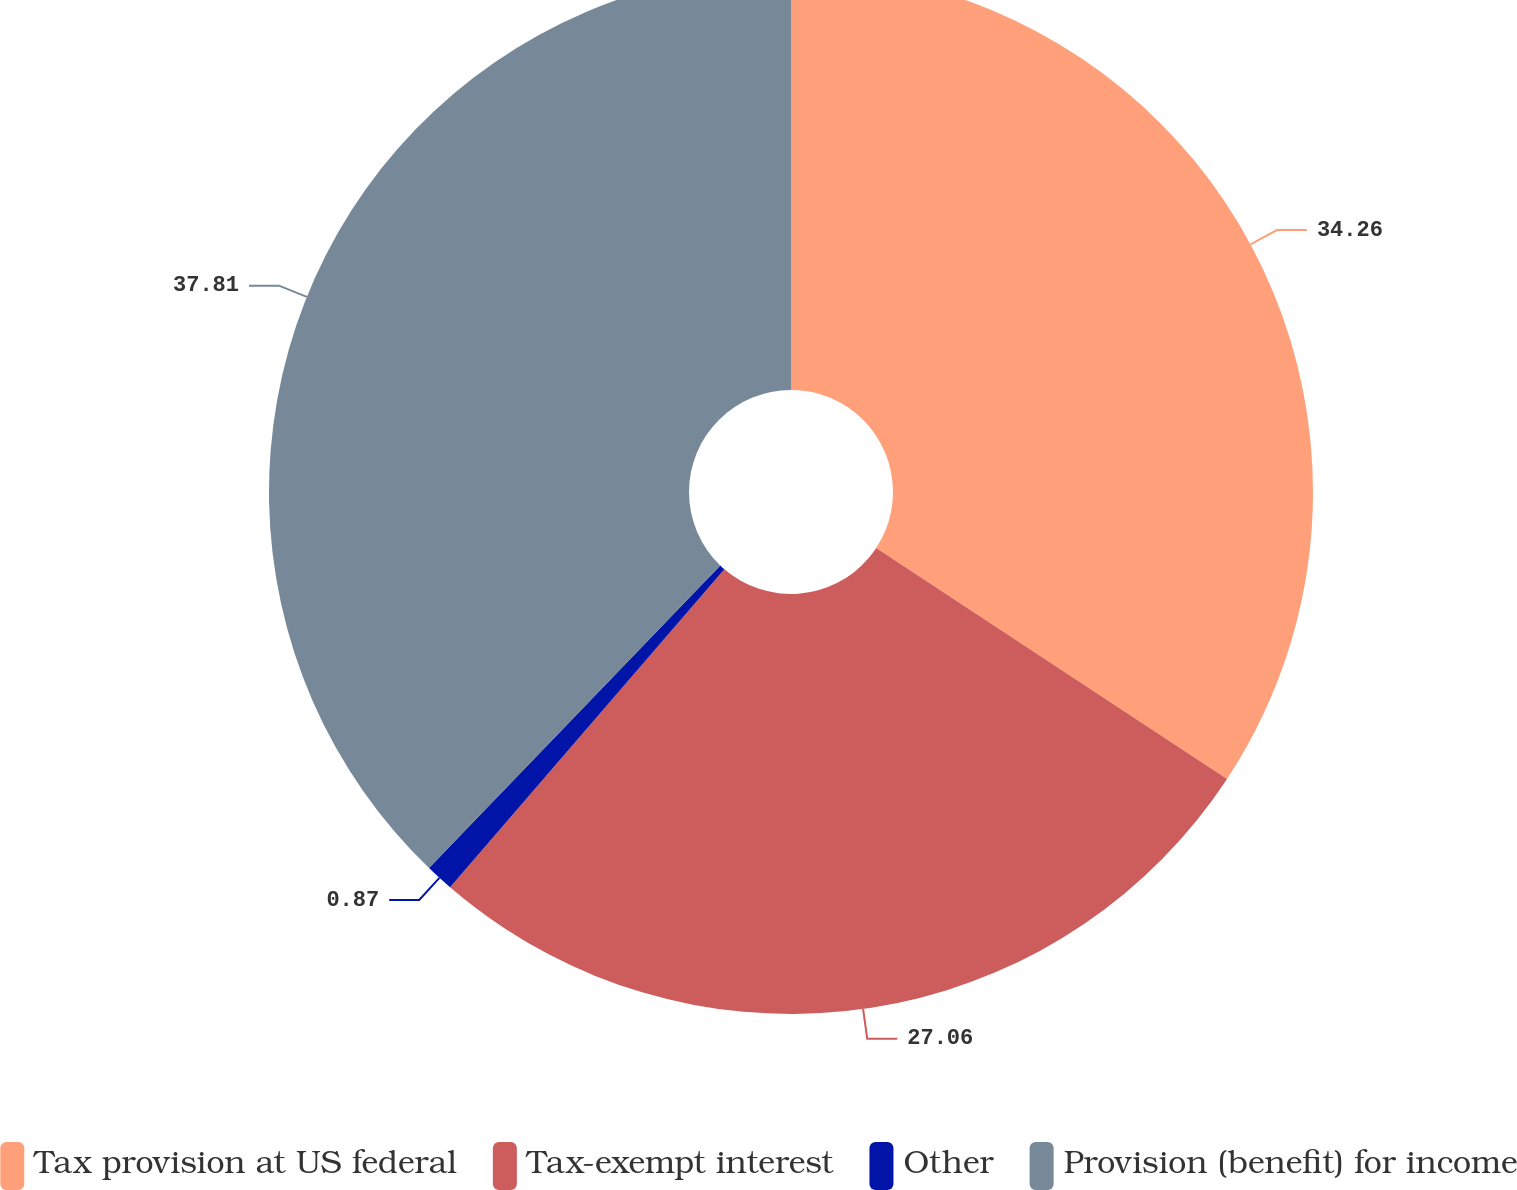Convert chart to OTSL. <chart><loc_0><loc_0><loc_500><loc_500><pie_chart><fcel>Tax provision at US federal<fcel>Tax-exempt interest<fcel>Other<fcel>Provision (benefit) for income<nl><fcel>34.26%<fcel>27.06%<fcel>0.87%<fcel>37.8%<nl></chart> 